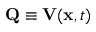Convert formula to latex. <formula><loc_0><loc_0><loc_500><loc_500>{ Q } \equiv V ( { x } , t )</formula> 